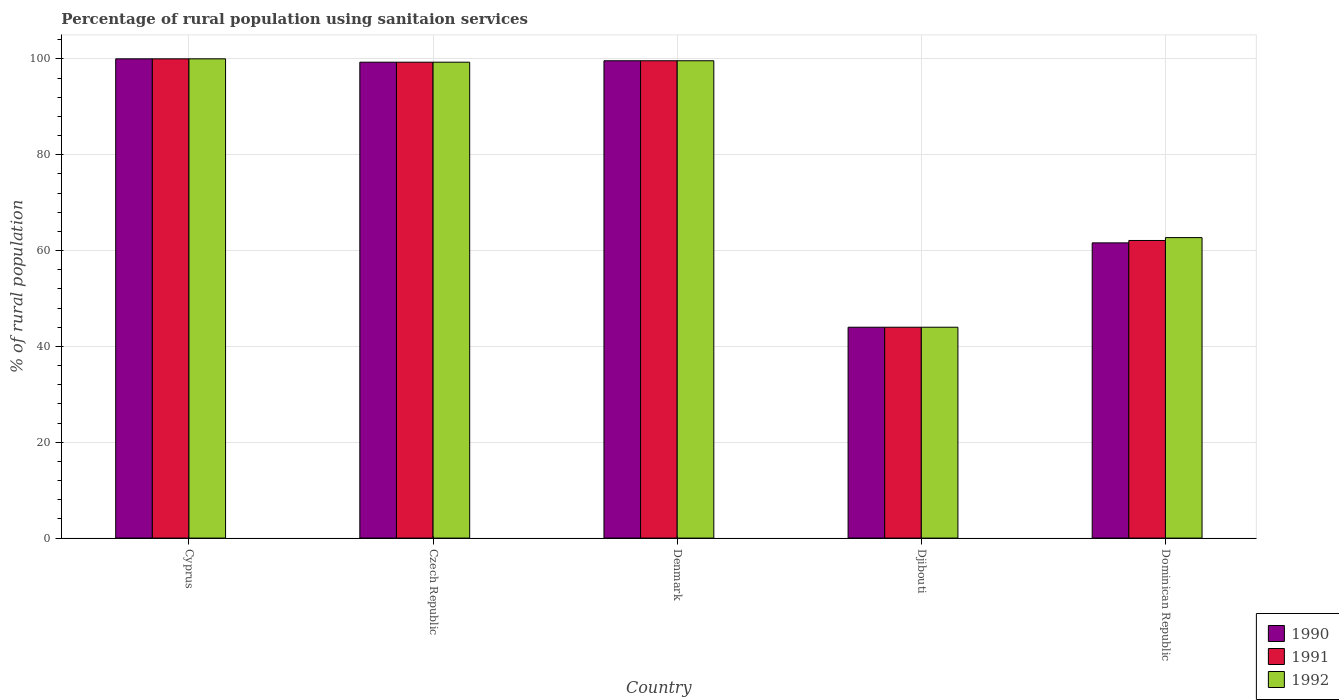How many different coloured bars are there?
Keep it short and to the point. 3. How many groups of bars are there?
Ensure brevity in your answer.  5. Are the number of bars on each tick of the X-axis equal?
Your answer should be very brief. Yes. What is the label of the 2nd group of bars from the left?
Provide a succinct answer. Czech Republic. In how many cases, is the number of bars for a given country not equal to the number of legend labels?
Your answer should be compact. 0. Across all countries, what is the maximum percentage of rural population using sanitaion services in 1991?
Your response must be concise. 100. In which country was the percentage of rural population using sanitaion services in 1992 maximum?
Provide a succinct answer. Cyprus. In which country was the percentage of rural population using sanitaion services in 1992 minimum?
Make the answer very short. Djibouti. What is the total percentage of rural population using sanitaion services in 1990 in the graph?
Give a very brief answer. 404.5. What is the difference between the percentage of rural population using sanitaion services in 1990 in Czech Republic and that in Dominican Republic?
Your response must be concise. 37.7. What is the difference between the percentage of rural population using sanitaion services in 1991 in Czech Republic and the percentage of rural population using sanitaion services in 1992 in Denmark?
Your answer should be compact. -0.3. What is the average percentage of rural population using sanitaion services in 1991 per country?
Offer a very short reply. 81. What is the difference between the percentage of rural population using sanitaion services of/in 1990 and percentage of rural population using sanitaion services of/in 1992 in Czech Republic?
Your response must be concise. 0. What is the ratio of the percentage of rural population using sanitaion services in 1992 in Czech Republic to that in Denmark?
Provide a short and direct response. 1. Is the percentage of rural population using sanitaion services in 1992 in Denmark less than that in Djibouti?
Give a very brief answer. No. What is the difference between the highest and the second highest percentage of rural population using sanitaion services in 1992?
Your response must be concise. -0.3. What is the difference between the highest and the lowest percentage of rural population using sanitaion services in 1990?
Give a very brief answer. 56. In how many countries, is the percentage of rural population using sanitaion services in 1990 greater than the average percentage of rural population using sanitaion services in 1990 taken over all countries?
Offer a terse response. 3. Is it the case that in every country, the sum of the percentage of rural population using sanitaion services in 1992 and percentage of rural population using sanitaion services in 1991 is greater than the percentage of rural population using sanitaion services in 1990?
Offer a very short reply. Yes. How many bars are there?
Provide a short and direct response. 15. How many countries are there in the graph?
Your response must be concise. 5. How are the legend labels stacked?
Your answer should be compact. Vertical. What is the title of the graph?
Offer a terse response. Percentage of rural population using sanitaion services. What is the label or title of the Y-axis?
Make the answer very short. % of rural population. What is the % of rural population in 1992 in Cyprus?
Offer a very short reply. 100. What is the % of rural population in 1990 in Czech Republic?
Provide a short and direct response. 99.3. What is the % of rural population in 1991 in Czech Republic?
Provide a succinct answer. 99.3. What is the % of rural population of 1992 in Czech Republic?
Offer a terse response. 99.3. What is the % of rural population of 1990 in Denmark?
Your response must be concise. 99.6. What is the % of rural population of 1991 in Denmark?
Give a very brief answer. 99.6. What is the % of rural population in 1992 in Denmark?
Offer a terse response. 99.6. What is the % of rural population of 1990 in Djibouti?
Provide a succinct answer. 44. What is the % of rural population in 1991 in Djibouti?
Your response must be concise. 44. What is the % of rural population of 1990 in Dominican Republic?
Your answer should be compact. 61.6. What is the % of rural population of 1991 in Dominican Republic?
Your answer should be very brief. 62.1. What is the % of rural population in 1992 in Dominican Republic?
Ensure brevity in your answer.  62.7. Across all countries, what is the minimum % of rural population in 1992?
Offer a terse response. 44. What is the total % of rural population in 1990 in the graph?
Offer a terse response. 404.5. What is the total % of rural population in 1991 in the graph?
Offer a very short reply. 405. What is the total % of rural population in 1992 in the graph?
Make the answer very short. 405.6. What is the difference between the % of rural population in 1990 in Cyprus and that in Czech Republic?
Your answer should be very brief. 0.7. What is the difference between the % of rural population of 1992 in Cyprus and that in Czech Republic?
Provide a succinct answer. 0.7. What is the difference between the % of rural population of 1991 in Cyprus and that in Djibouti?
Your response must be concise. 56. What is the difference between the % of rural population in 1992 in Cyprus and that in Djibouti?
Your answer should be compact. 56. What is the difference between the % of rural population of 1990 in Cyprus and that in Dominican Republic?
Offer a terse response. 38.4. What is the difference between the % of rural population in 1991 in Cyprus and that in Dominican Republic?
Provide a short and direct response. 37.9. What is the difference between the % of rural population of 1992 in Cyprus and that in Dominican Republic?
Ensure brevity in your answer.  37.3. What is the difference between the % of rural population of 1990 in Czech Republic and that in Denmark?
Give a very brief answer. -0.3. What is the difference between the % of rural population of 1992 in Czech Republic and that in Denmark?
Ensure brevity in your answer.  -0.3. What is the difference between the % of rural population of 1990 in Czech Republic and that in Djibouti?
Ensure brevity in your answer.  55.3. What is the difference between the % of rural population of 1991 in Czech Republic and that in Djibouti?
Ensure brevity in your answer.  55.3. What is the difference between the % of rural population in 1992 in Czech Republic and that in Djibouti?
Provide a short and direct response. 55.3. What is the difference between the % of rural population of 1990 in Czech Republic and that in Dominican Republic?
Make the answer very short. 37.7. What is the difference between the % of rural population in 1991 in Czech Republic and that in Dominican Republic?
Provide a short and direct response. 37.2. What is the difference between the % of rural population in 1992 in Czech Republic and that in Dominican Republic?
Your answer should be very brief. 36.6. What is the difference between the % of rural population of 1990 in Denmark and that in Djibouti?
Ensure brevity in your answer.  55.6. What is the difference between the % of rural population in 1991 in Denmark and that in Djibouti?
Your answer should be very brief. 55.6. What is the difference between the % of rural population in 1992 in Denmark and that in Djibouti?
Ensure brevity in your answer.  55.6. What is the difference between the % of rural population of 1990 in Denmark and that in Dominican Republic?
Offer a terse response. 38. What is the difference between the % of rural population of 1991 in Denmark and that in Dominican Republic?
Provide a succinct answer. 37.5. What is the difference between the % of rural population of 1992 in Denmark and that in Dominican Republic?
Provide a succinct answer. 36.9. What is the difference between the % of rural population of 1990 in Djibouti and that in Dominican Republic?
Your answer should be compact. -17.6. What is the difference between the % of rural population in 1991 in Djibouti and that in Dominican Republic?
Offer a terse response. -18.1. What is the difference between the % of rural population of 1992 in Djibouti and that in Dominican Republic?
Keep it short and to the point. -18.7. What is the difference between the % of rural population in 1990 in Cyprus and the % of rural population in 1991 in Czech Republic?
Provide a succinct answer. 0.7. What is the difference between the % of rural population in 1991 in Cyprus and the % of rural population in 1992 in Czech Republic?
Give a very brief answer. 0.7. What is the difference between the % of rural population in 1990 in Cyprus and the % of rural population in 1992 in Denmark?
Provide a succinct answer. 0.4. What is the difference between the % of rural population of 1991 in Cyprus and the % of rural population of 1992 in Denmark?
Keep it short and to the point. 0.4. What is the difference between the % of rural population in 1990 in Cyprus and the % of rural population in 1991 in Djibouti?
Offer a very short reply. 56. What is the difference between the % of rural population of 1991 in Cyprus and the % of rural population of 1992 in Djibouti?
Give a very brief answer. 56. What is the difference between the % of rural population in 1990 in Cyprus and the % of rural population in 1991 in Dominican Republic?
Offer a terse response. 37.9. What is the difference between the % of rural population of 1990 in Cyprus and the % of rural population of 1992 in Dominican Republic?
Keep it short and to the point. 37.3. What is the difference between the % of rural population of 1991 in Cyprus and the % of rural population of 1992 in Dominican Republic?
Provide a succinct answer. 37.3. What is the difference between the % of rural population in 1990 in Czech Republic and the % of rural population in 1992 in Denmark?
Make the answer very short. -0.3. What is the difference between the % of rural population in 1991 in Czech Republic and the % of rural population in 1992 in Denmark?
Make the answer very short. -0.3. What is the difference between the % of rural population in 1990 in Czech Republic and the % of rural population in 1991 in Djibouti?
Ensure brevity in your answer.  55.3. What is the difference between the % of rural population of 1990 in Czech Republic and the % of rural population of 1992 in Djibouti?
Your response must be concise. 55.3. What is the difference between the % of rural population of 1991 in Czech Republic and the % of rural population of 1992 in Djibouti?
Your response must be concise. 55.3. What is the difference between the % of rural population of 1990 in Czech Republic and the % of rural population of 1991 in Dominican Republic?
Keep it short and to the point. 37.2. What is the difference between the % of rural population in 1990 in Czech Republic and the % of rural population in 1992 in Dominican Republic?
Your answer should be very brief. 36.6. What is the difference between the % of rural population of 1991 in Czech Republic and the % of rural population of 1992 in Dominican Republic?
Ensure brevity in your answer.  36.6. What is the difference between the % of rural population in 1990 in Denmark and the % of rural population in 1991 in Djibouti?
Ensure brevity in your answer.  55.6. What is the difference between the % of rural population of 1990 in Denmark and the % of rural population of 1992 in Djibouti?
Ensure brevity in your answer.  55.6. What is the difference between the % of rural population in 1991 in Denmark and the % of rural population in 1992 in Djibouti?
Your answer should be compact. 55.6. What is the difference between the % of rural population in 1990 in Denmark and the % of rural population in 1991 in Dominican Republic?
Offer a terse response. 37.5. What is the difference between the % of rural population in 1990 in Denmark and the % of rural population in 1992 in Dominican Republic?
Your answer should be very brief. 36.9. What is the difference between the % of rural population of 1991 in Denmark and the % of rural population of 1992 in Dominican Republic?
Provide a short and direct response. 36.9. What is the difference between the % of rural population in 1990 in Djibouti and the % of rural population in 1991 in Dominican Republic?
Make the answer very short. -18.1. What is the difference between the % of rural population in 1990 in Djibouti and the % of rural population in 1992 in Dominican Republic?
Offer a very short reply. -18.7. What is the difference between the % of rural population in 1991 in Djibouti and the % of rural population in 1992 in Dominican Republic?
Make the answer very short. -18.7. What is the average % of rural population in 1990 per country?
Offer a very short reply. 80.9. What is the average % of rural population in 1992 per country?
Your response must be concise. 81.12. What is the difference between the % of rural population of 1990 and % of rural population of 1991 in Cyprus?
Offer a very short reply. 0. What is the difference between the % of rural population of 1990 and % of rural population of 1992 in Cyprus?
Your response must be concise. 0. What is the difference between the % of rural population in 1991 and % of rural population in 1992 in Cyprus?
Your answer should be compact. 0. What is the difference between the % of rural population of 1990 and % of rural population of 1991 in Czech Republic?
Make the answer very short. 0. What is the difference between the % of rural population of 1990 and % of rural population of 1992 in Czech Republic?
Your answer should be very brief. 0. What is the difference between the % of rural population of 1991 and % of rural population of 1992 in Czech Republic?
Keep it short and to the point. 0. What is the difference between the % of rural population of 1990 and % of rural population of 1992 in Denmark?
Ensure brevity in your answer.  0. What is the difference between the % of rural population of 1991 and % of rural population of 1992 in Denmark?
Keep it short and to the point. 0. What is the difference between the % of rural population of 1990 and % of rural population of 1992 in Djibouti?
Offer a terse response. 0. What is the difference between the % of rural population in 1990 and % of rural population in 1991 in Dominican Republic?
Ensure brevity in your answer.  -0.5. What is the difference between the % of rural population of 1991 and % of rural population of 1992 in Dominican Republic?
Make the answer very short. -0.6. What is the ratio of the % of rural population in 1990 in Cyprus to that in Czech Republic?
Ensure brevity in your answer.  1.01. What is the ratio of the % of rural population of 1990 in Cyprus to that in Denmark?
Offer a very short reply. 1. What is the ratio of the % of rural population of 1992 in Cyprus to that in Denmark?
Provide a succinct answer. 1. What is the ratio of the % of rural population of 1990 in Cyprus to that in Djibouti?
Offer a very short reply. 2.27. What is the ratio of the % of rural population of 1991 in Cyprus to that in Djibouti?
Your answer should be very brief. 2.27. What is the ratio of the % of rural population in 1992 in Cyprus to that in Djibouti?
Your response must be concise. 2.27. What is the ratio of the % of rural population in 1990 in Cyprus to that in Dominican Republic?
Provide a succinct answer. 1.62. What is the ratio of the % of rural population of 1991 in Cyprus to that in Dominican Republic?
Ensure brevity in your answer.  1.61. What is the ratio of the % of rural population in 1992 in Cyprus to that in Dominican Republic?
Your response must be concise. 1.59. What is the ratio of the % of rural population in 1990 in Czech Republic to that in Denmark?
Your answer should be very brief. 1. What is the ratio of the % of rural population in 1990 in Czech Republic to that in Djibouti?
Offer a very short reply. 2.26. What is the ratio of the % of rural population of 1991 in Czech Republic to that in Djibouti?
Offer a terse response. 2.26. What is the ratio of the % of rural population of 1992 in Czech Republic to that in Djibouti?
Give a very brief answer. 2.26. What is the ratio of the % of rural population of 1990 in Czech Republic to that in Dominican Republic?
Provide a short and direct response. 1.61. What is the ratio of the % of rural population of 1991 in Czech Republic to that in Dominican Republic?
Give a very brief answer. 1.6. What is the ratio of the % of rural population of 1992 in Czech Republic to that in Dominican Republic?
Offer a terse response. 1.58. What is the ratio of the % of rural population of 1990 in Denmark to that in Djibouti?
Your answer should be compact. 2.26. What is the ratio of the % of rural population of 1991 in Denmark to that in Djibouti?
Your response must be concise. 2.26. What is the ratio of the % of rural population of 1992 in Denmark to that in Djibouti?
Keep it short and to the point. 2.26. What is the ratio of the % of rural population of 1990 in Denmark to that in Dominican Republic?
Provide a short and direct response. 1.62. What is the ratio of the % of rural population of 1991 in Denmark to that in Dominican Republic?
Your answer should be compact. 1.6. What is the ratio of the % of rural population of 1992 in Denmark to that in Dominican Republic?
Your answer should be very brief. 1.59. What is the ratio of the % of rural population in 1991 in Djibouti to that in Dominican Republic?
Give a very brief answer. 0.71. What is the ratio of the % of rural population in 1992 in Djibouti to that in Dominican Republic?
Provide a short and direct response. 0.7. What is the difference between the highest and the second highest % of rural population in 1990?
Provide a short and direct response. 0.4. What is the difference between the highest and the second highest % of rural population of 1991?
Your answer should be compact. 0.4. What is the difference between the highest and the second highest % of rural population of 1992?
Offer a terse response. 0.4. What is the difference between the highest and the lowest % of rural population of 1991?
Your answer should be very brief. 56. What is the difference between the highest and the lowest % of rural population of 1992?
Offer a terse response. 56. 